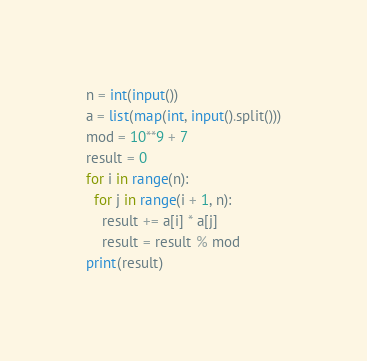<code> <loc_0><loc_0><loc_500><loc_500><_Python_>n = int(input())
a = list(map(int, input().split()))
mod = 10**9 + 7
result = 0
for i in range(n):
  for j in range(i + 1, n):
    result += a[i] * a[j]
    result = result % mod
print(result)</code> 